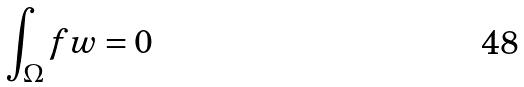Convert formula to latex. <formula><loc_0><loc_0><loc_500><loc_500>\int _ { \Omega } f w = 0</formula> 